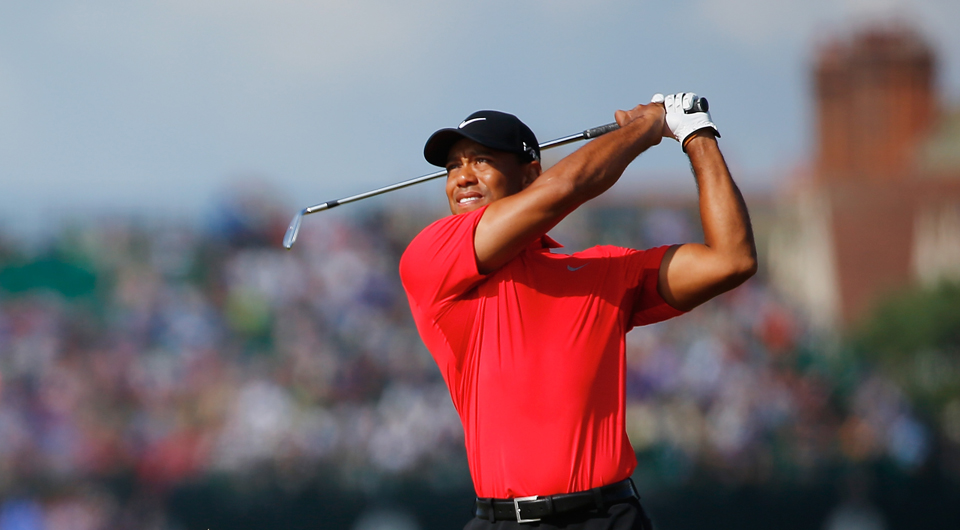Describe a scenario where this image is part of a historical documentary. In a historical documentary, this image could be used to highlight a pivotal moment in the golfer's career. The narration might speak of breakthroughs, achievements, and the sheer dedication involved in reaching such a level of skill. It might describe the crowd's excitement and the significance of the event, perhaps focusing on a particularly memorable or record-breaking tournament. Interviews with fans, sports analysts, and the golfer themselves could be woven in to provide deeper insight into the historical value and impact of this moment on the sport of golf. 